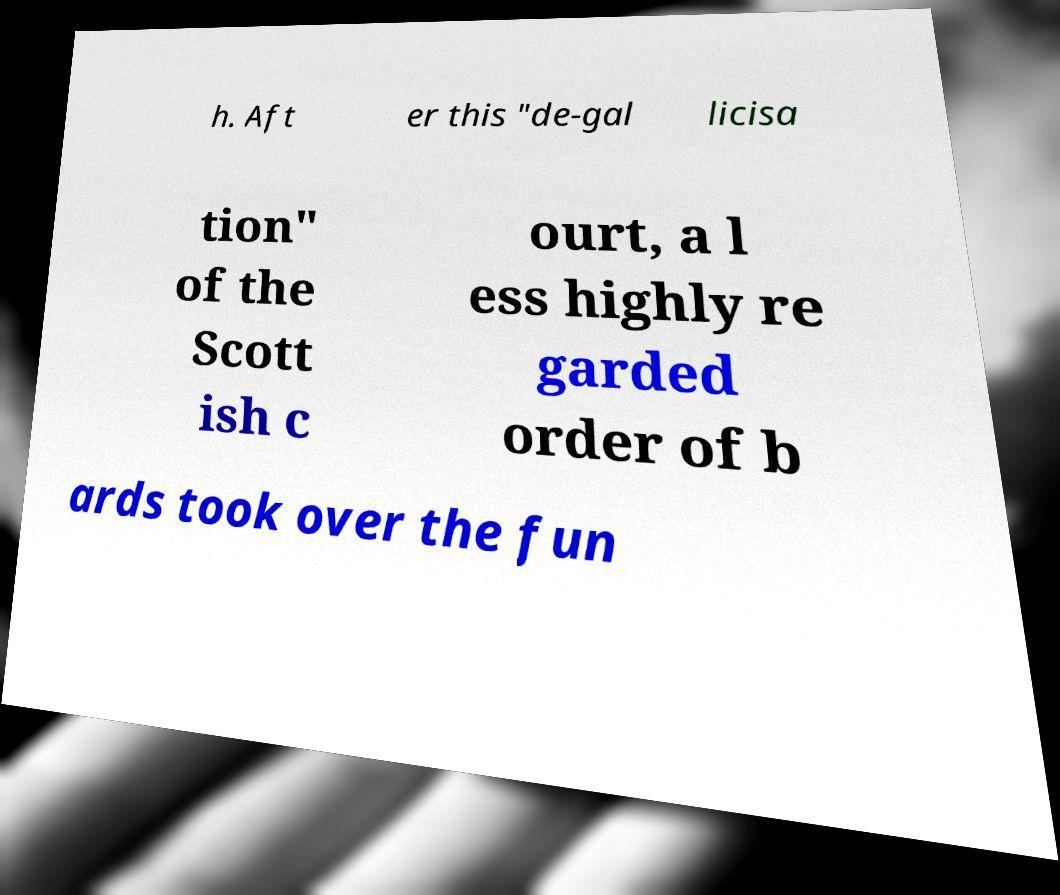Could you extract and type out the text from this image? h. Aft er this "de-gal licisa tion" of the Scott ish c ourt, a l ess highly re garded order of b ards took over the fun 